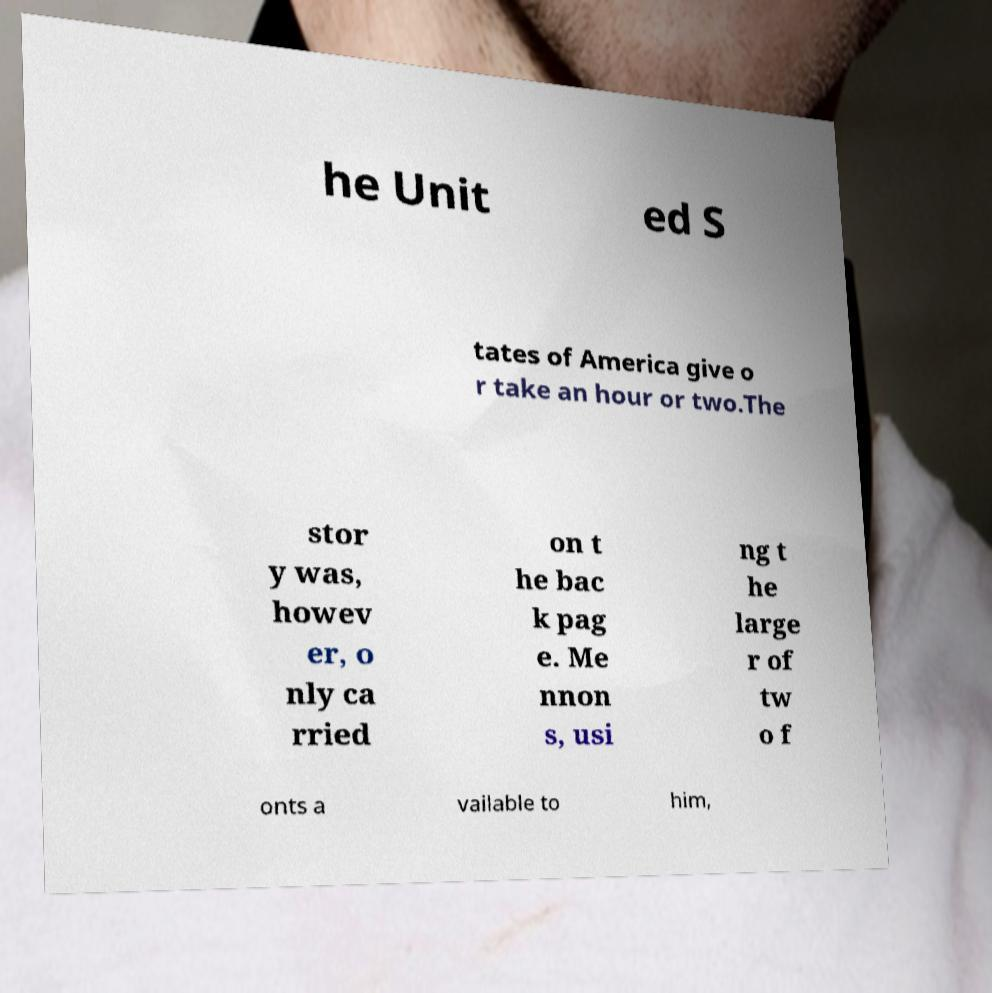What messages or text are displayed in this image? I need them in a readable, typed format. he Unit ed S tates of America give o r take an hour or two.The stor y was, howev er, o nly ca rried on t he bac k pag e. Me nnon s, usi ng t he large r of tw o f onts a vailable to him, 